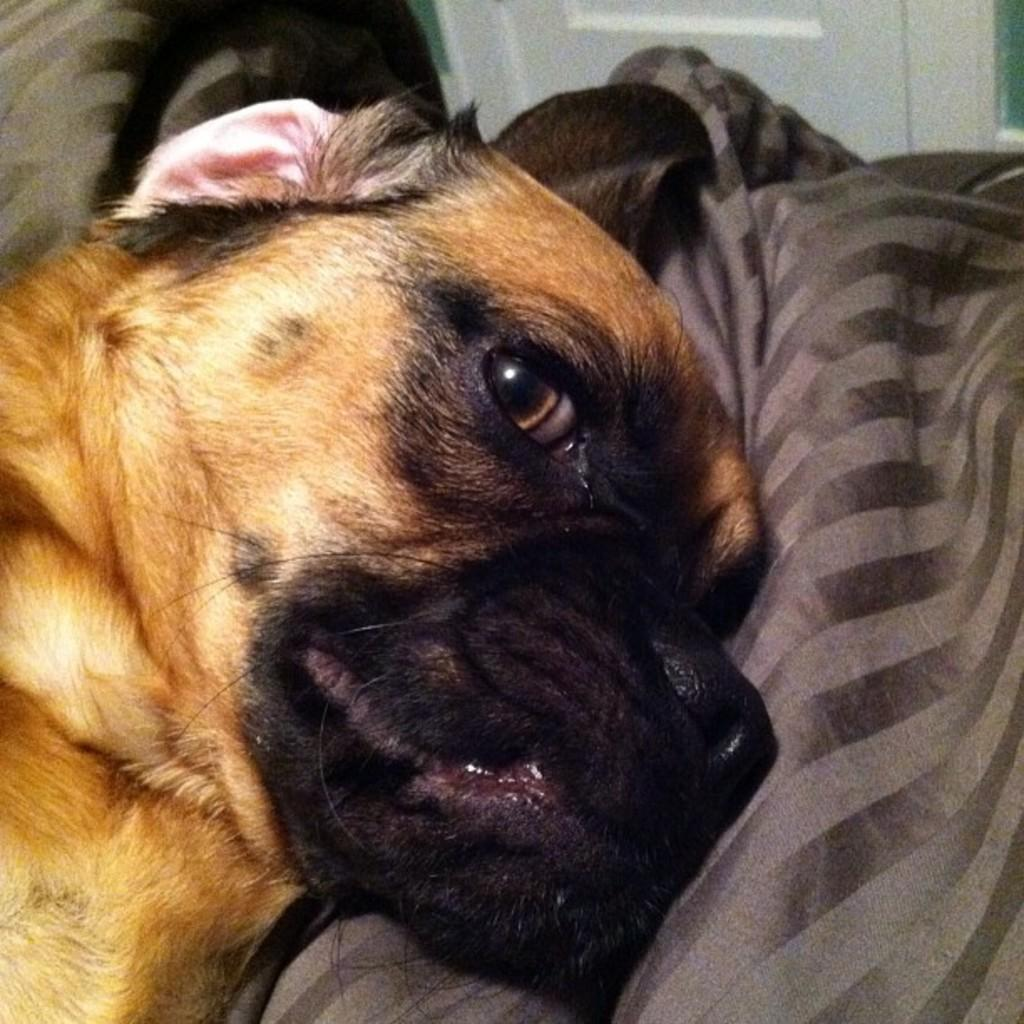What type of animal is in the image? There is a dog in the image. What is the dog sitting or lying on? The dog is on a cloth. What can be seen in the background of the image? There is a door in the background of the image. Reasoning: Let' Let's think step by step in order to produce the conversation. We start by identifying the main subject in the image, which is the dog. Then, we describe the dog's position and what it is on, which is a cloth. Finally, we mention the background of the image, which includes a door. Each question is designed to elicit a specific detail about the image that is known from the provided facts. Absurd Question/Answer: What subject is the dog interested in at school in the image? There is no indication of a school or subject in the image; it simply features a dog on a cloth with a door in the background. 